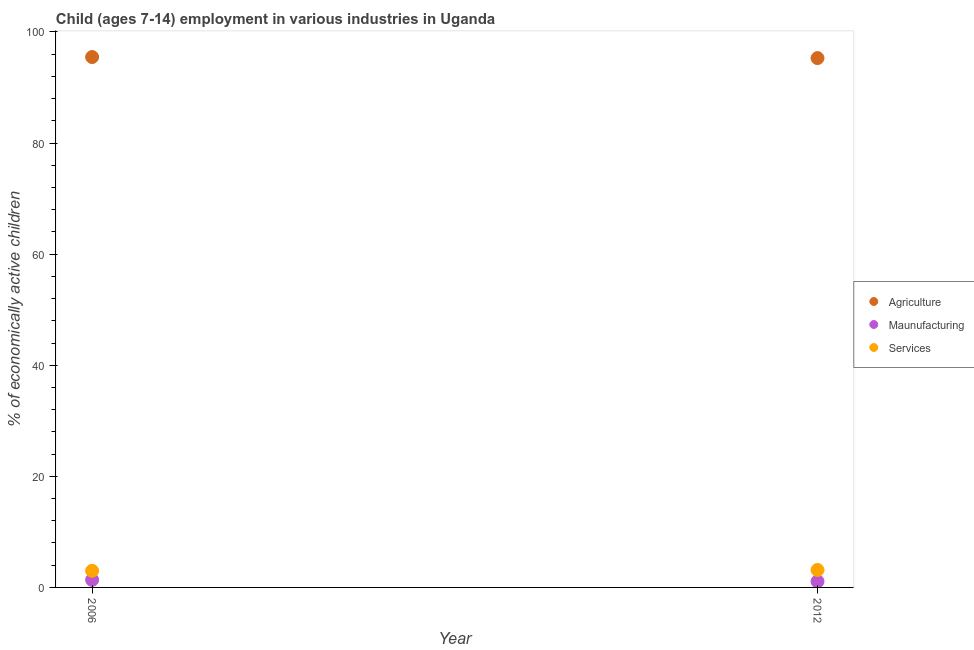How many different coloured dotlines are there?
Give a very brief answer. 3. Is the number of dotlines equal to the number of legend labels?
Offer a very short reply. Yes. What is the percentage of economically active children in services in 2012?
Give a very brief answer. 3.14. Across all years, what is the maximum percentage of economically active children in manufacturing?
Give a very brief answer. 1.36. Across all years, what is the minimum percentage of economically active children in manufacturing?
Offer a very short reply. 1.09. In which year was the percentage of economically active children in manufacturing maximum?
Offer a very short reply. 2006. In which year was the percentage of economically active children in manufacturing minimum?
Ensure brevity in your answer.  2012. What is the total percentage of economically active children in services in the graph?
Make the answer very short. 6.13. What is the difference between the percentage of economically active children in manufacturing in 2006 and that in 2012?
Offer a terse response. 0.27. What is the difference between the percentage of economically active children in manufacturing in 2006 and the percentage of economically active children in services in 2012?
Provide a succinct answer. -1.78. What is the average percentage of economically active children in agriculture per year?
Offer a very short reply. 95.39. In the year 2006, what is the difference between the percentage of economically active children in services and percentage of economically active children in agriculture?
Keep it short and to the point. -92.49. In how many years, is the percentage of economically active children in manufacturing greater than 20 %?
Make the answer very short. 0. What is the ratio of the percentage of economically active children in services in 2006 to that in 2012?
Your answer should be very brief. 0.95. Is the percentage of economically active children in agriculture in 2006 less than that in 2012?
Provide a short and direct response. No. Is it the case that in every year, the sum of the percentage of economically active children in agriculture and percentage of economically active children in manufacturing is greater than the percentage of economically active children in services?
Give a very brief answer. Yes. Is the percentage of economically active children in manufacturing strictly less than the percentage of economically active children in services over the years?
Offer a very short reply. Yes. How many dotlines are there?
Your response must be concise. 3. What is the difference between two consecutive major ticks on the Y-axis?
Keep it short and to the point. 20. Are the values on the major ticks of Y-axis written in scientific E-notation?
Your response must be concise. No. Where does the legend appear in the graph?
Keep it short and to the point. Center right. How many legend labels are there?
Give a very brief answer. 3. What is the title of the graph?
Make the answer very short. Child (ages 7-14) employment in various industries in Uganda. Does "Spain" appear as one of the legend labels in the graph?
Your answer should be compact. No. What is the label or title of the X-axis?
Keep it short and to the point. Year. What is the label or title of the Y-axis?
Give a very brief answer. % of economically active children. What is the % of economically active children of Agriculture in 2006?
Provide a short and direct response. 95.48. What is the % of economically active children in Maunufacturing in 2006?
Provide a succinct answer. 1.36. What is the % of economically active children in Services in 2006?
Offer a very short reply. 2.99. What is the % of economically active children of Agriculture in 2012?
Provide a short and direct response. 95.29. What is the % of economically active children of Maunufacturing in 2012?
Offer a terse response. 1.09. What is the % of economically active children in Services in 2012?
Ensure brevity in your answer.  3.14. Across all years, what is the maximum % of economically active children of Agriculture?
Your response must be concise. 95.48. Across all years, what is the maximum % of economically active children in Maunufacturing?
Keep it short and to the point. 1.36. Across all years, what is the maximum % of economically active children of Services?
Offer a terse response. 3.14. Across all years, what is the minimum % of economically active children in Agriculture?
Provide a succinct answer. 95.29. Across all years, what is the minimum % of economically active children of Maunufacturing?
Provide a succinct answer. 1.09. Across all years, what is the minimum % of economically active children in Services?
Keep it short and to the point. 2.99. What is the total % of economically active children in Agriculture in the graph?
Provide a short and direct response. 190.77. What is the total % of economically active children in Maunufacturing in the graph?
Make the answer very short. 2.45. What is the total % of economically active children of Services in the graph?
Offer a terse response. 6.13. What is the difference between the % of economically active children of Agriculture in 2006 and that in 2012?
Offer a terse response. 0.19. What is the difference between the % of economically active children in Maunufacturing in 2006 and that in 2012?
Provide a short and direct response. 0.27. What is the difference between the % of economically active children in Services in 2006 and that in 2012?
Your response must be concise. -0.15. What is the difference between the % of economically active children of Agriculture in 2006 and the % of economically active children of Maunufacturing in 2012?
Offer a very short reply. 94.39. What is the difference between the % of economically active children in Agriculture in 2006 and the % of economically active children in Services in 2012?
Provide a succinct answer. 92.34. What is the difference between the % of economically active children in Maunufacturing in 2006 and the % of economically active children in Services in 2012?
Provide a succinct answer. -1.78. What is the average % of economically active children of Agriculture per year?
Provide a short and direct response. 95.39. What is the average % of economically active children in Maunufacturing per year?
Your response must be concise. 1.23. What is the average % of economically active children of Services per year?
Provide a short and direct response. 3.06. In the year 2006, what is the difference between the % of economically active children in Agriculture and % of economically active children in Maunufacturing?
Keep it short and to the point. 94.12. In the year 2006, what is the difference between the % of economically active children in Agriculture and % of economically active children in Services?
Ensure brevity in your answer.  92.49. In the year 2006, what is the difference between the % of economically active children of Maunufacturing and % of economically active children of Services?
Give a very brief answer. -1.63. In the year 2012, what is the difference between the % of economically active children of Agriculture and % of economically active children of Maunufacturing?
Give a very brief answer. 94.2. In the year 2012, what is the difference between the % of economically active children of Agriculture and % of economically active children of Services?
Provide a short and direct response. 92.15. In the year 2012, what is the difference between the % of economically active children in Maunufacturing and % of economically active children in Services?
Provide a succinct answer. -2.05. What is the ratio of the % of economically active children of Agriculture in 2006 to that in 2012?
Your answer should be compact. 1. What is the ratio of the % of economically active children of Maunufacturing in 2006 to that in 2012?
Make the answer very short. 1.25. What is the ratio of the % of economically active children of Services in 2006 to that in 2012?
Make the answer very short. 0.95. What is the difference between the highest and the second highest % of economically active children in Agriculture?
Offer a terse response. 0.19. What is the difference between the highest and the second highest % of economically active children in Maunufacturing?
Give a very brief answer. 0.27. What is the difference between the highest and the second highest % of economically active children of Services?
Your response must be concise. 0.15. What is the difference between the highest and the lowest % of economically active children of Agriculture?
Provide a short and direct response. 0.19. What is the difference between the highest and the lowest % of economically active children of Maunufacturing?
Ensure brevity in your answer.  0.27. 